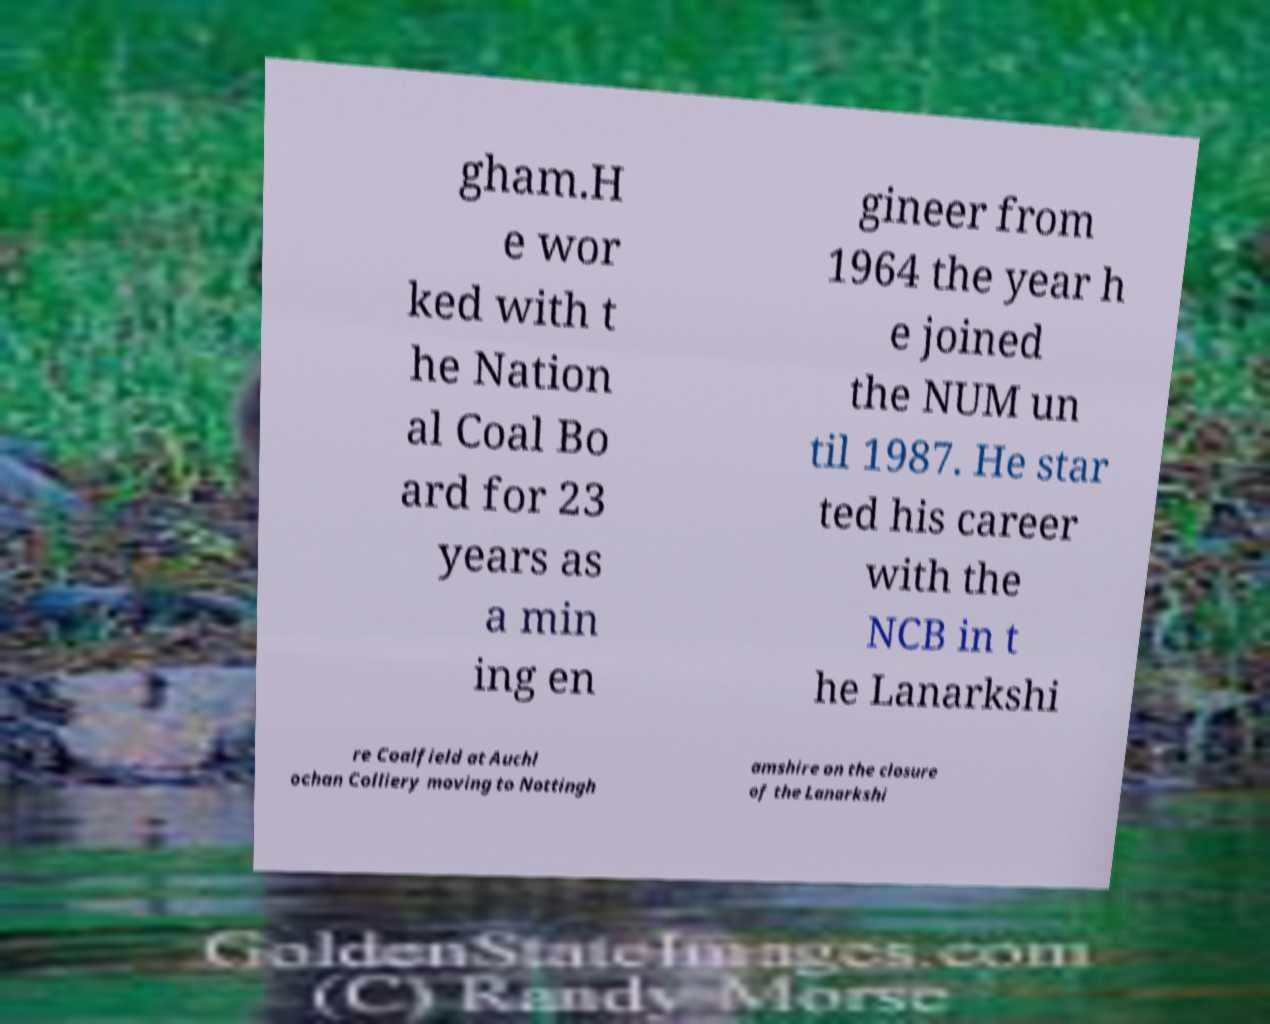Can you accurately transcribe the text from the provided image for me? gham.H e wor ked with t he Nation al Coal Bo ard for 23 years as a min ing en gineer from 1964 the year h e joined the NUM un til 1987. He star ted his career with the NCB in t he Lanarkshi re Coalfield at Auchl ochan Colliery moving to Nottingh amshire on the closure of the Lanarkshi 